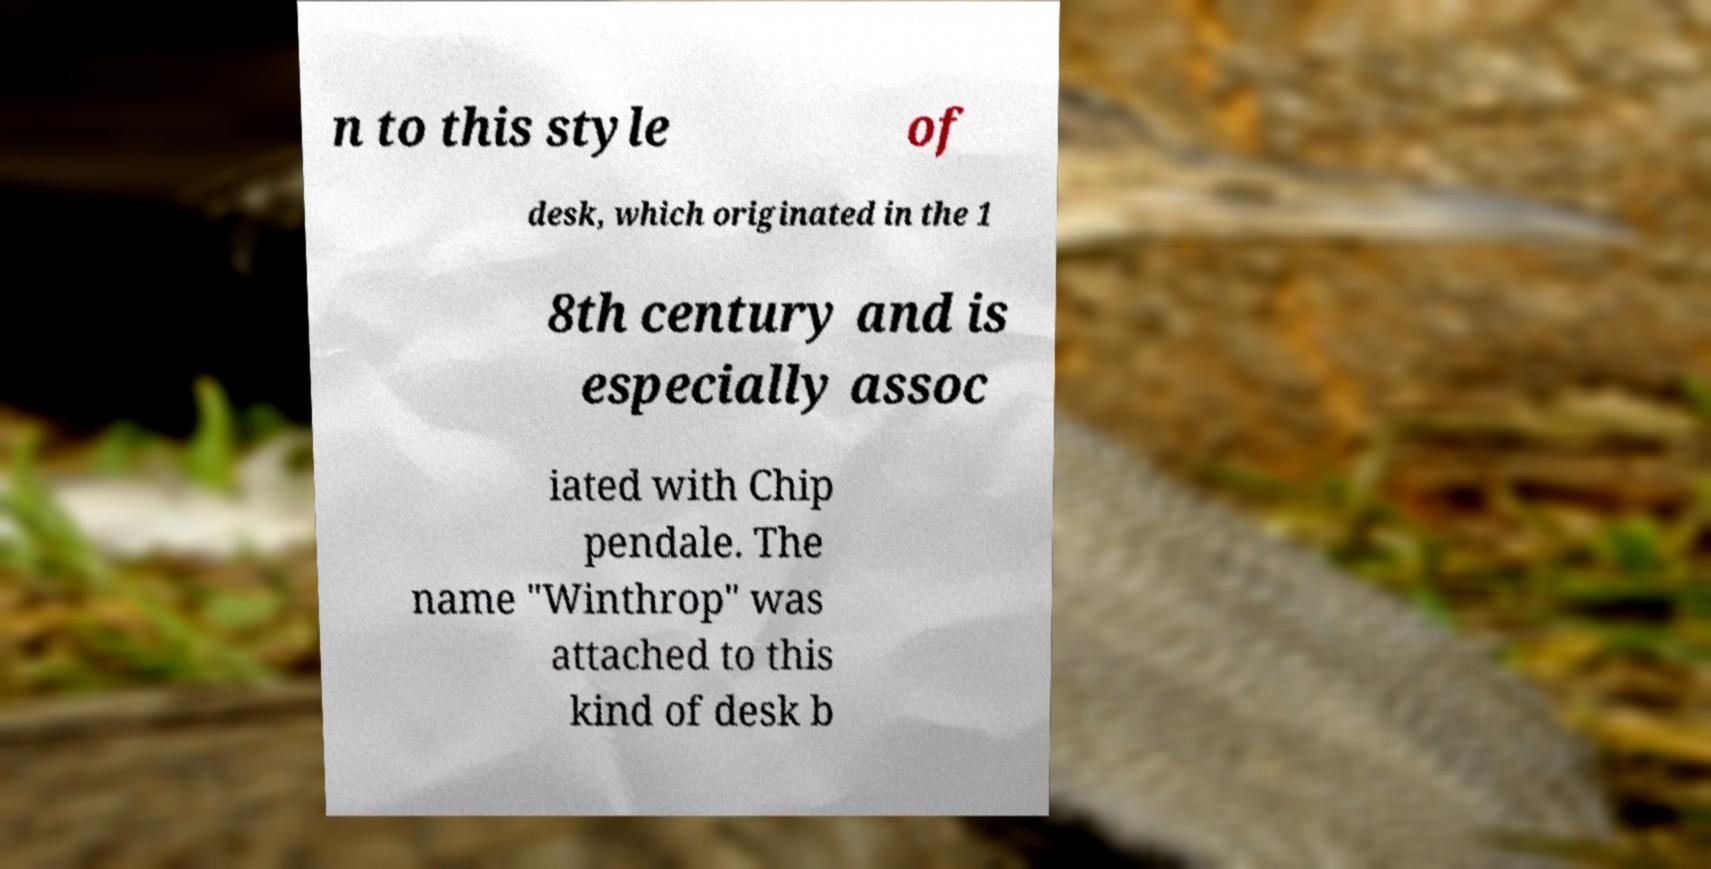I need the written content from this picture converted into text. Can you do that? n to this style of desk, which originated in the 1 8th century and is especially assoc iated with Chip pendale. The name "Winthrop" was attached to this kind of desk b 